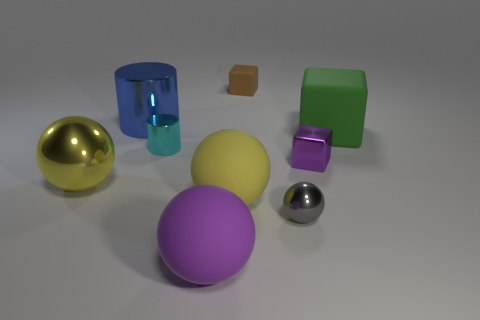Subtract all large spheres. How many spheres are left? 1 Add 1 large yellow shiny objects. How many objects exist? 10 Subtract all blue balls. Subtract all cyan cylinders. How many balls are left? 4 Subtract all cubes. How many objects are left? 6 Add 6 large matte cubes. How many large matte cubes exist? 7 Subtract 0 green cylinders. How many objects are left? 9 Subtract all tiny blue matte cylinders. Subtract all large green matte cubes. How many objects are left? 8 Add 1 small purple blocks. How many small purple blocks are left? 2 